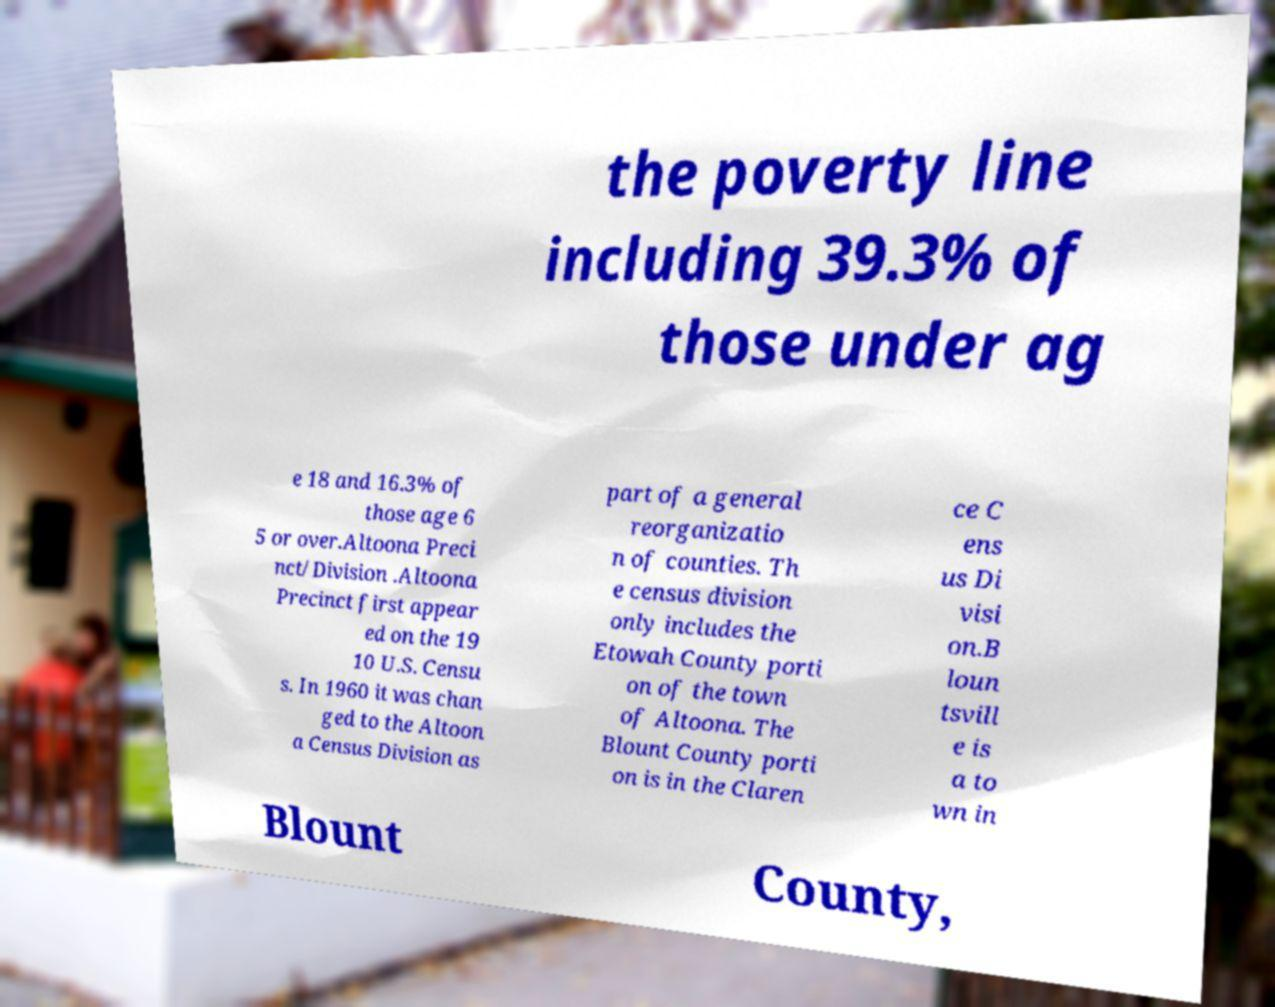What messages or text are displayed in this image? I need them in a readable, typed format. the poverty line including 39.3% of those under ag e 18 and 16.3% of those age 6 5 or over.Altoona Preci nct/Division .Altoona Precinct first appear ed on the 19 10 U.S. Censu s. In 1960 it was chan ged to the Altoon a Census Division as part of a general reorganizatio n of counties. Th e census division only includes the Etowah County porti on of the town of Altoona. The Blount County porti on is in the Claren ce C ens us Di visi on.B loun tsvill e is a to wn in Blount County, 